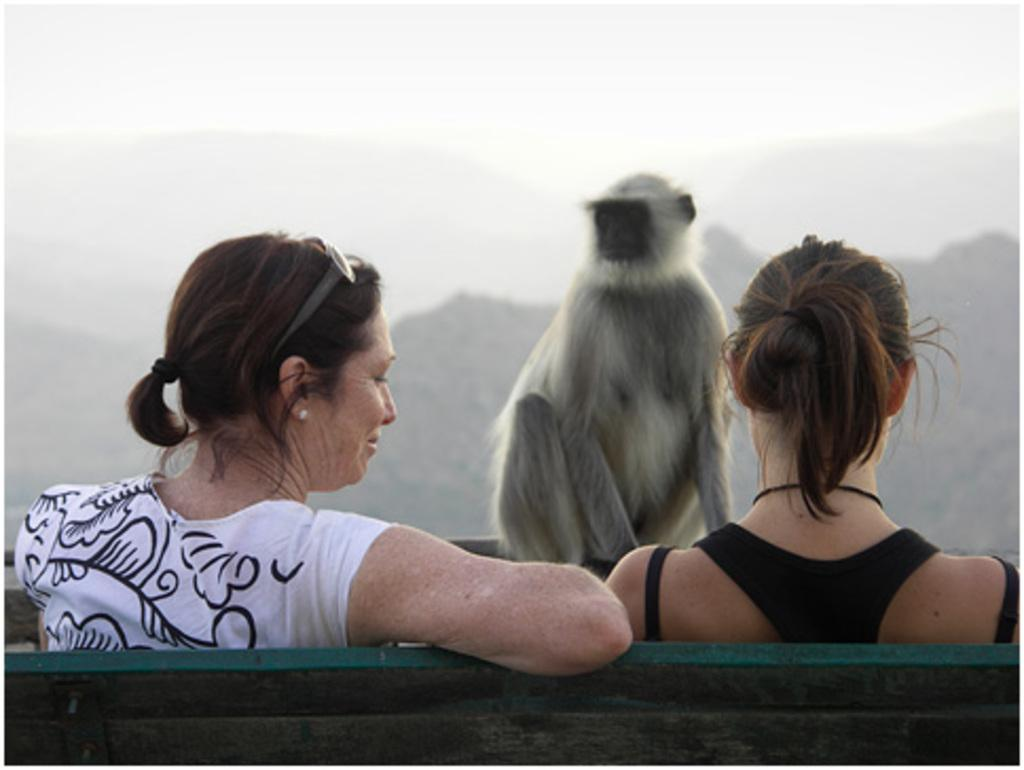How many people are sitting on the bench in the image? There are two women sitting on a bench in the image. What is the interaction between the two women? One woman is looking at the other person. What unexpected animal is present in the image? There is a monkey in front of the women. What can be seen in the background of the image? Mountains are visible in the distance. Where is the map located in the image? There is no map present in the image. What color is the orange on the bench? There is no orange present in the image. 